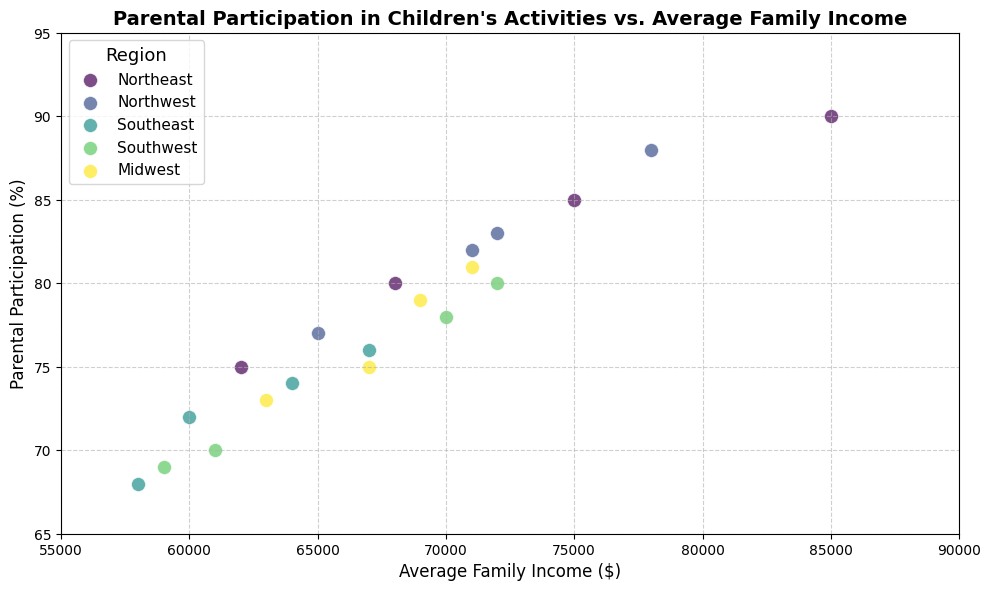What region has the highest parental participation percentage? The Northeast region has the highest parental participation of 90%, as indicated by the uppermost data point belonging to the Northeast region on the scatter plot.
Answer: Northeast Which region appears to have the lowest average family income? The Southeast region has the lowest data points in terms of average family income, with incomes as low as $58,000 visible on the plot.
Answer: Southeast Is there a general correlation between average family income and parental participation across the regions? Observing the scatter plot, there seems to be a positive correlation between higher average family incomes and higher parental participation percentages, as more of the data points on the higher end of both axes belong to the same dots.
Answer: Yes Among the plotted regions, which has the widest range of parental participation? The Northeast region has a participation range from 75% to 90%, making it the widest range of parental participation percentages visible in the plot.
Answer: Northeast Which region has the highest average parental participation percentage and how was this determined? The Northeast region has the highest average parental participation percentage, with numbers ranging from 75% to 90%. This was determined by recognizing the highest individual data points marked with the Northeast region legend in the plot.
Answer: Northeast What is the approximate difference between the highest and lowest parental participation percentages in the Southeast region? The highest participation in the Southeast is around 76%, and the lowest is about 68%. The difference is 76 - 68 = 8%.
Answer: 8% How does the parental participation in the Midwest compare to that in the Southwest for similar average incomes? The Midwest and Southwest have similar income ranges, but Midwest parental participation slightly trends higher (between 73% to 81%) than the Southwest (between 69% to 80%). This comparison is visible in the scatter plot colors and alignments.
Answer: Midwest is higher Which region has the most concentrated cluster of data points and what does this indicate? The Midwest region has closely clustered data points, indicating more uniform levels of family income and parental participation compared to other regions.
Answer: Midwest 